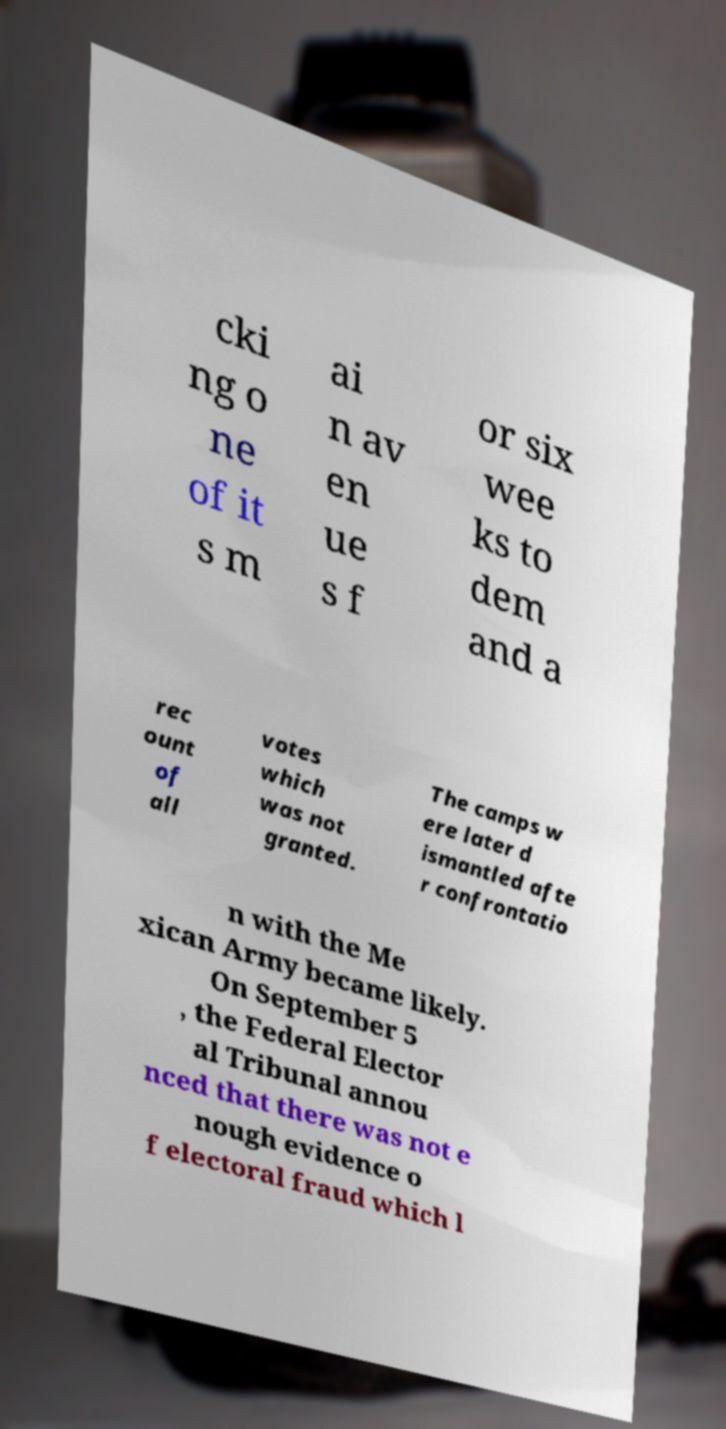I need the written content from this picture converted into text. Can you do that? cki ng o ne of it s m ai n av en ue s f or six wee ks to dem and a rec ount of all votes which was not granted. The camps w ere later d ismantled afte r confrontatio n with the Me xican Army became likely. On September 5 , the Federal Elector al Tribunal annou nced that there was not e nough evidence o f electoral fraud which l 